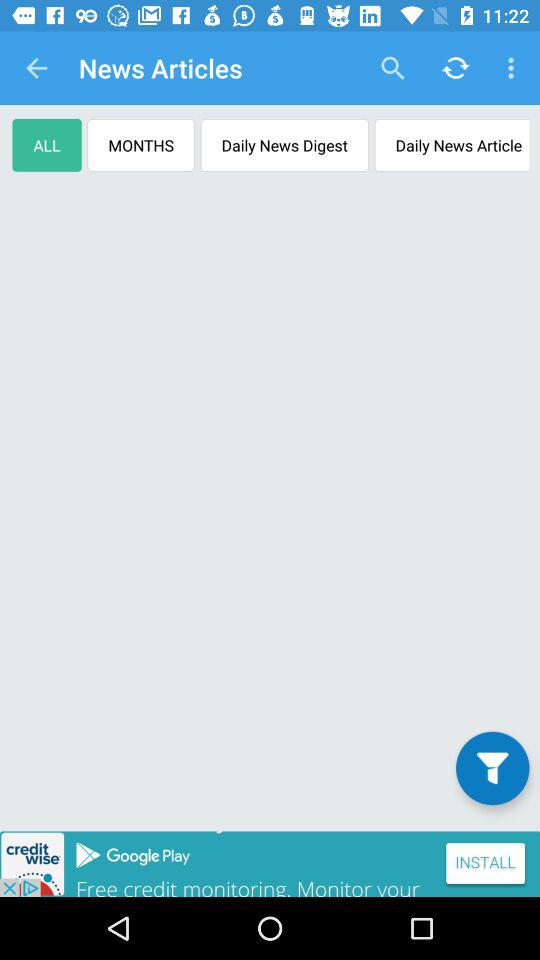How many notifications are there in "MONTHS"?
When the provided information is insufficient, respond with <no answer>. <no answer> 